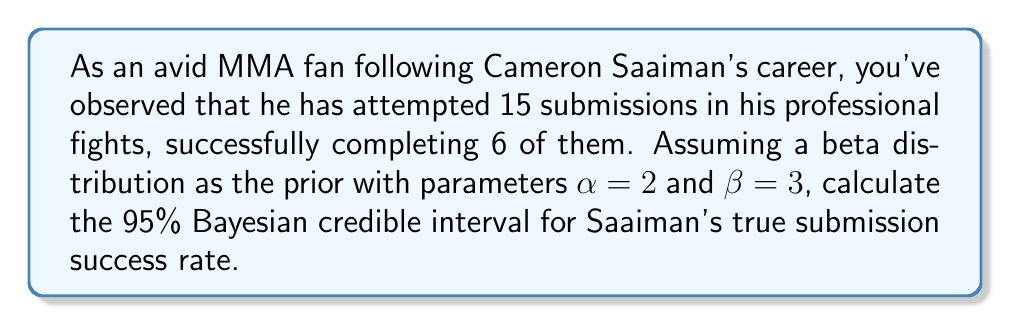Teach me how to tackle this problem. To calculate the Bayesian credible interval, we'll follow these steps:

1) The prior distribution is Beta(2,3).
2) We have observed 6 successes out of 15 attempts.
3) The posterior distribution is Beta($\alpha + x, \beta + n - x$), where:
   $\alpha = 2$ (prior parameter)
   $\beta = 3$ (prior parameter)
   $x = 6$ (observed successes)
   $n = 15$ (total attempts)

4) Therefore, the posterior distribution is Beta(8, 12).

5) For a 95% credible interval of a Beta(a,b) distribution, we need to find the 2.5th and 97.5th percentiles.

6) We can use the inverse of the cumulative beta distribution function (quantile function) to find these percentiles:

   Lower bound: $q_{Beta(8,12)}(0.025)$
   Upper bound: $q_{Beta(8,12)}(0.975)$

7) Using a statistical software or calculator, we get:
   Lower bound ≈ 0.2481
   Upper bound ≈ 0.6499

Therefore, we can be 95% confident that Saaiman's true submission success rate lies between 24.81% and 64.99%.
Answer: [0.2481, 0.6499] 